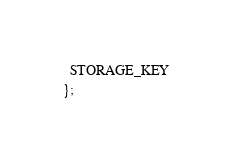<code> <loc_0><loc_0><loc_500><loc_500><_JavaScript_>  STORAGE_KEY
};
</code> 